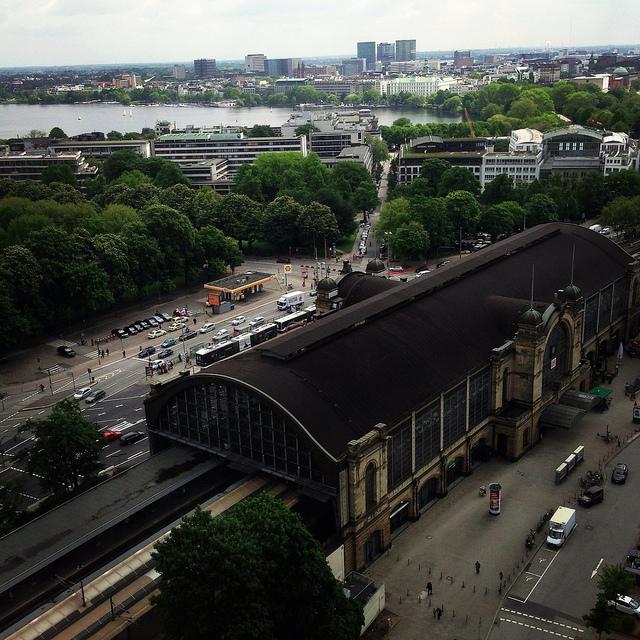Is it night or day?
Concise answer only. Day. Is this an aerial photo?
Give a very brief answer. Yes. What type of vehicles are shown?
Concise answer only. Cars. What does the big building appear to be?
Be succinct. Train station. 